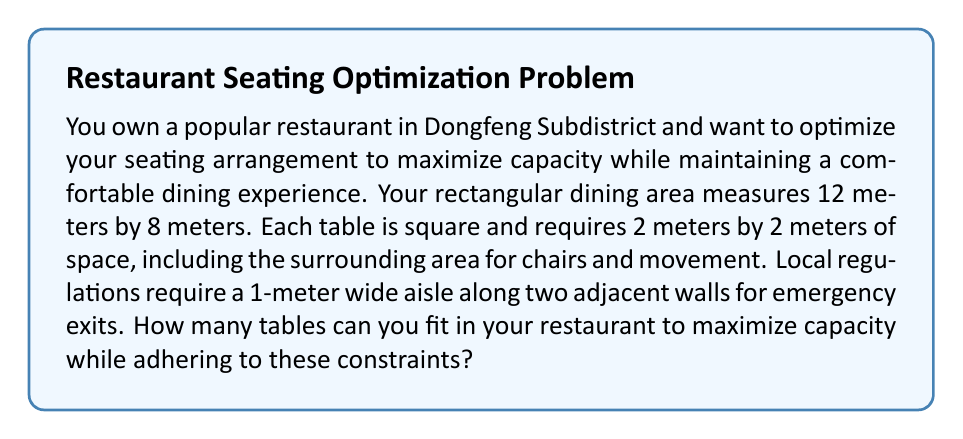Provide a solution to this math problem. Let's approach this problem step by step:

1) First, we need to account for the required aisle space. This reduces our usable area:
   - Length: $12 - 1 = 11$ meters
   - Width: $8 - 1 = 7$ meters

2) Now, we need to determine how many 2m x 2m spaces we can fit in this 11m x 7m area.

3) For the length (11m):
   $$\text{Number of tables along length} = \left\lfloor\frac{11}{2}\right\rfloor = 5$$
   Where $\lfloor \cdot \rfloor$ denotes the floor function.

4) For the width (7m):
   $$\text{Number of tables along width} = \left\lfloor\frac{7}{2}\right\rfloor = 3$$

5) The total number of tables is the product of these two values:
   $$\text{Total tables} = 5 \times 3 = 15$$

6) Let's verify that this fits within our constraints:
   - Length used: $5 \times 2 = 10$ meters (leaving 1m, which satisfies the aisle requirement)
   - Width used: $3 \times 2 = 6$ meters (leaving 1m, which satisfies the aisle requirement)

Therefore, we can fit 15 tables while adhering to all constraints, maximizing our restaurant's capacity.
Answer: 15 tables 